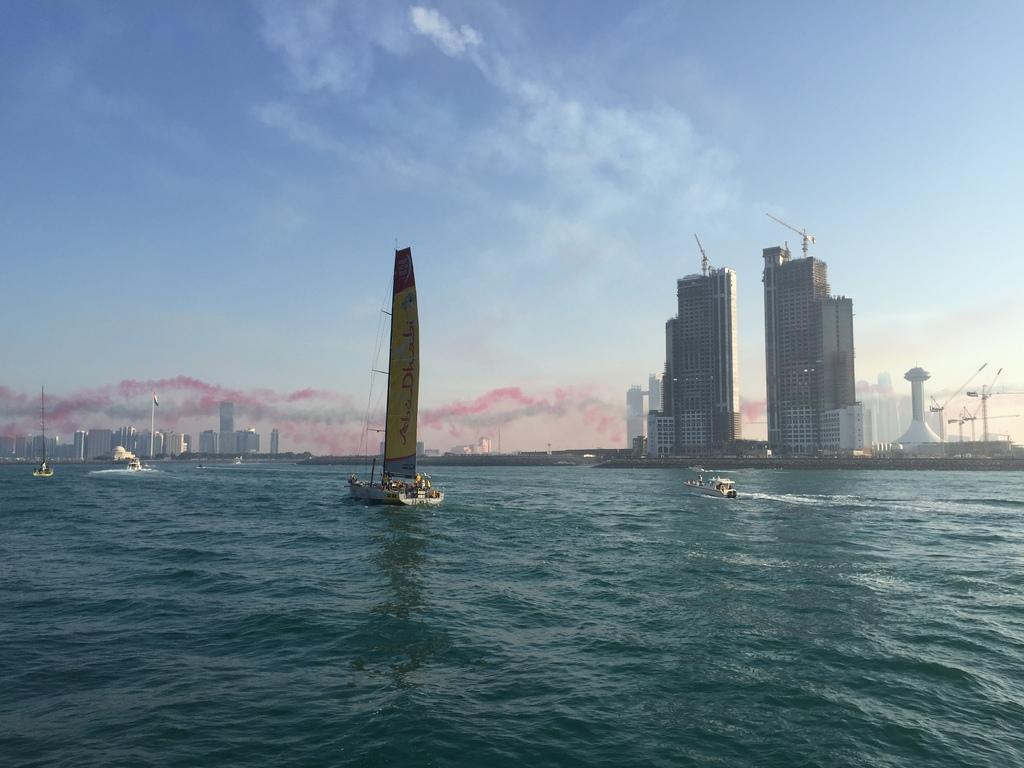What type of vehicles are in the water in the image? There are boats in the water in the image. What can be seen in the background of the image? There are buildings and the sky visible in the background. Where is the throne located in the image? There is no throne present in the image. What is the aftermath of the boats in the image? The image does not depict an aftermath; it shows boats in the water and buildings in the background. 